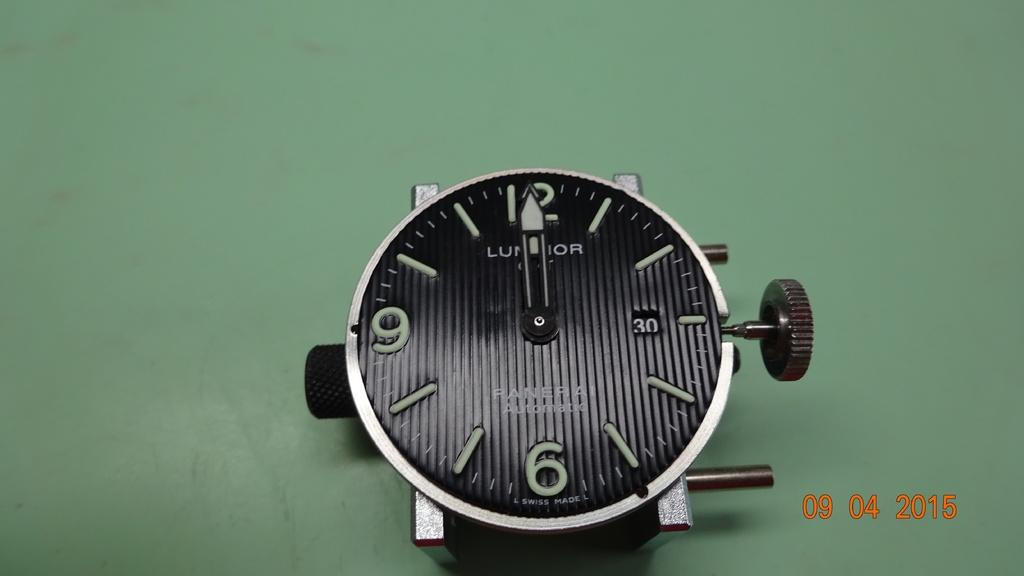<image>
Describe the image concisely. An old black watch that says Panerai is on a green background. 